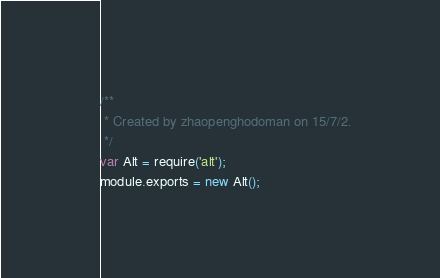<code> <loc_0><loc_0><loc_500><loc_500><_JavaScript_>/**
 * Created by zhaopenghodoman on 15/7/2.
 */
var Alt = require('alt');
module.exports = new Alt();</code> 